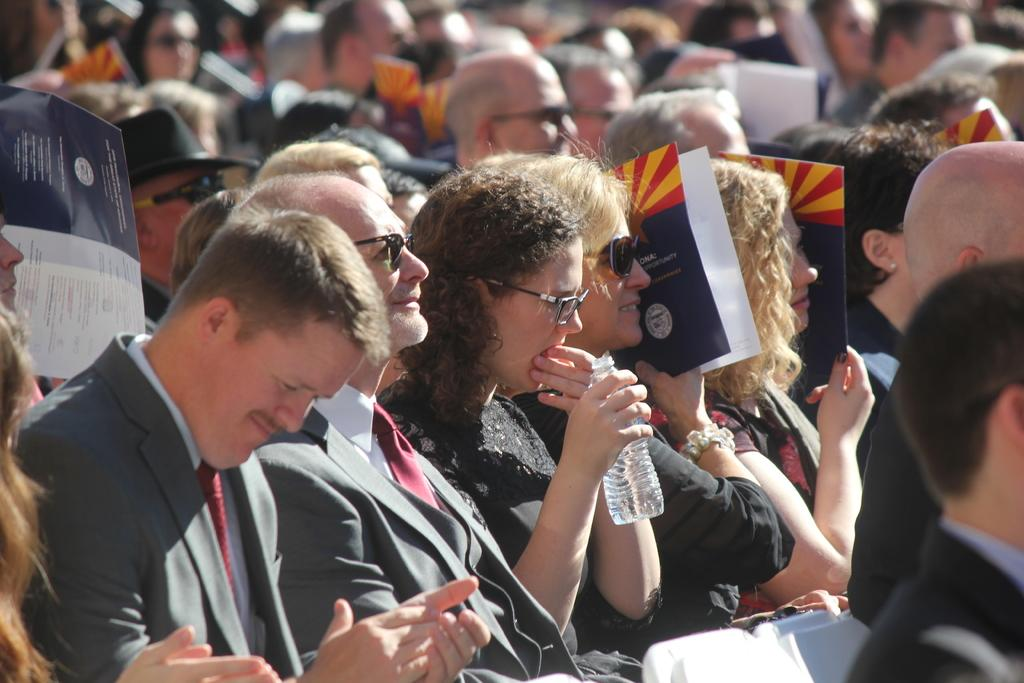What are the people in the image doing? The people in the image are sitting on chairs and holding brochures in their hands. Can you describe the woman in the center of the image? The woman in the center of the image is holding a water bottle in her hand. What might the people be doing with the brochures? The people might be reading or discussing the information in the brochures. What type of cream is being applied to the woman's hair in the image? There is no cream being applied to anyone's hair in the image. What kind of brush is the woman using to paint the chairs in the image? There is no painting or brushes visible in the image; the people are holding brochures. 